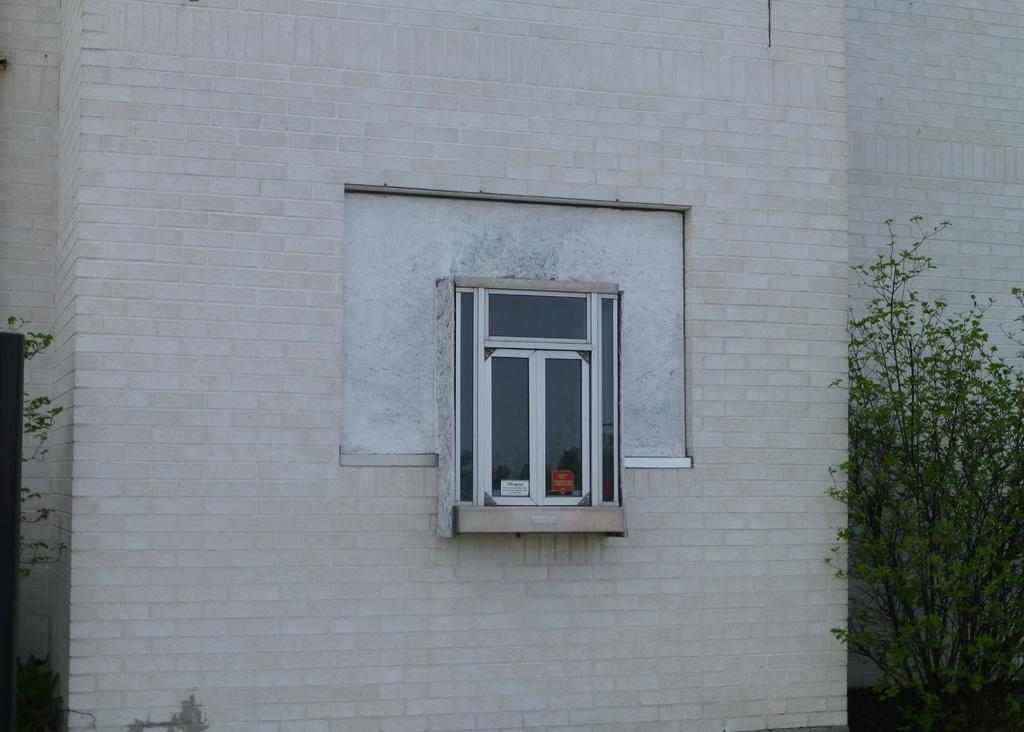What type of structure is in the image? There is a white building in the image. Can you describe any specific features of the building? The building has a window in the middle. What is located on either side of the window? There are plants on either side of the window. What type of bone can be seen supporting the building in the image? There is no bone present in the image, and the building is not supported by any bones. 